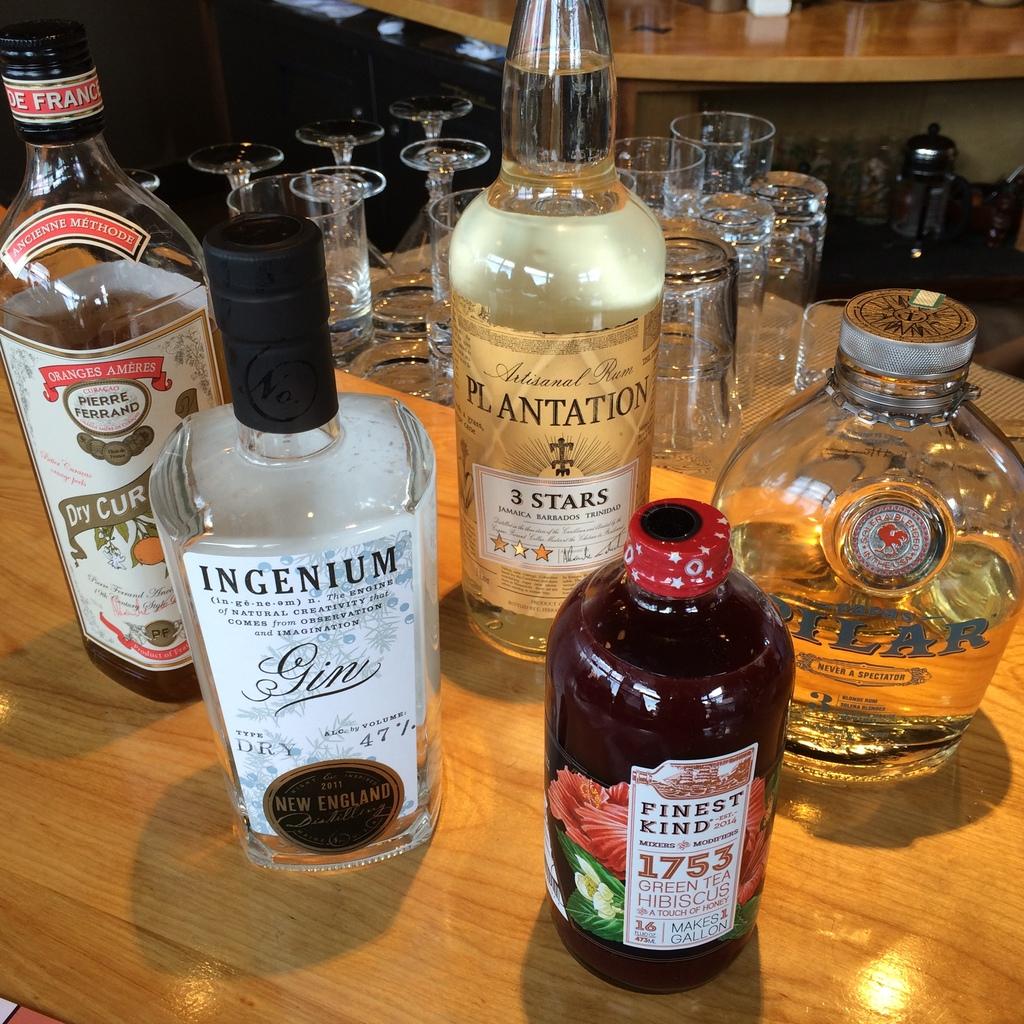How much tea can you make with the green tea hibiscus bottle?
Your answer should be very brief. 1 gallon. 